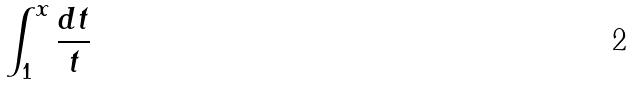Convert formula to latex. <formula><loc_0><loc_0><loc_500><loc_500>\int _ { 1 } ^ { x } \frac { d t } { t }</formula> 